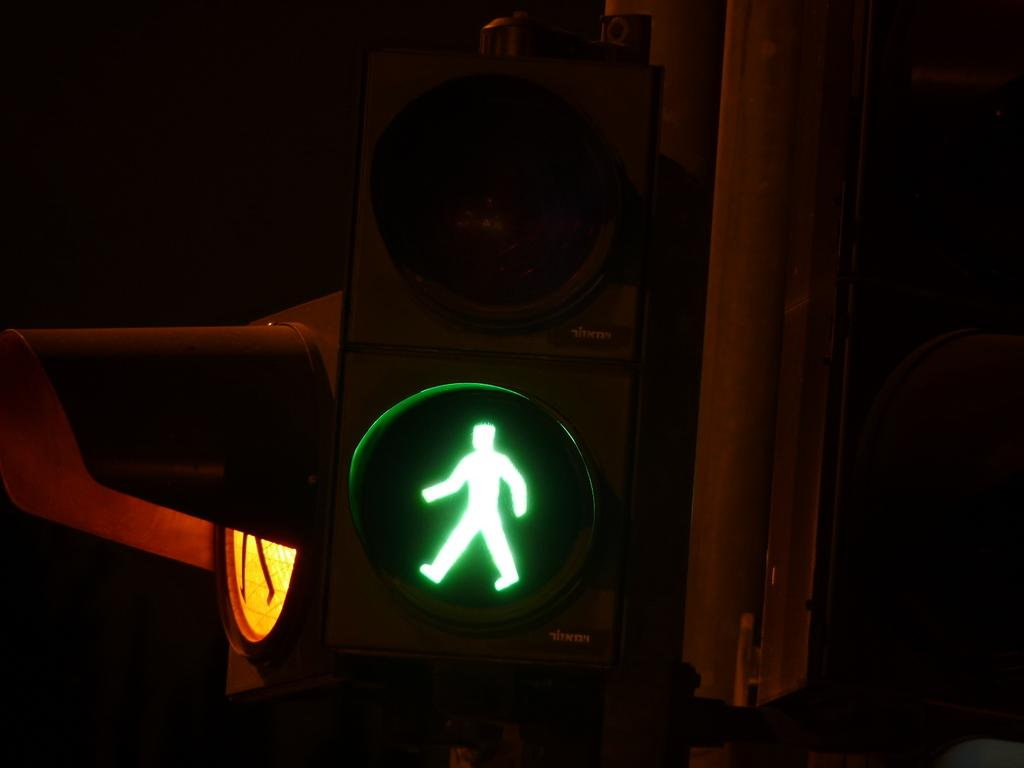What can be seen in the image that helps regulate traffic? There are traffic signals in the image. What is the tall, vertical object in the image? There is a pole in the image. How would you describe the overall lighting or brightness in the image? The background of the image has a dark view. Where is the doll sitting on the dock in the image? There is no doll or dock present in the image. On what type of furniture is the king sitting on his throne in the image? There is no king or throne present in the image. 